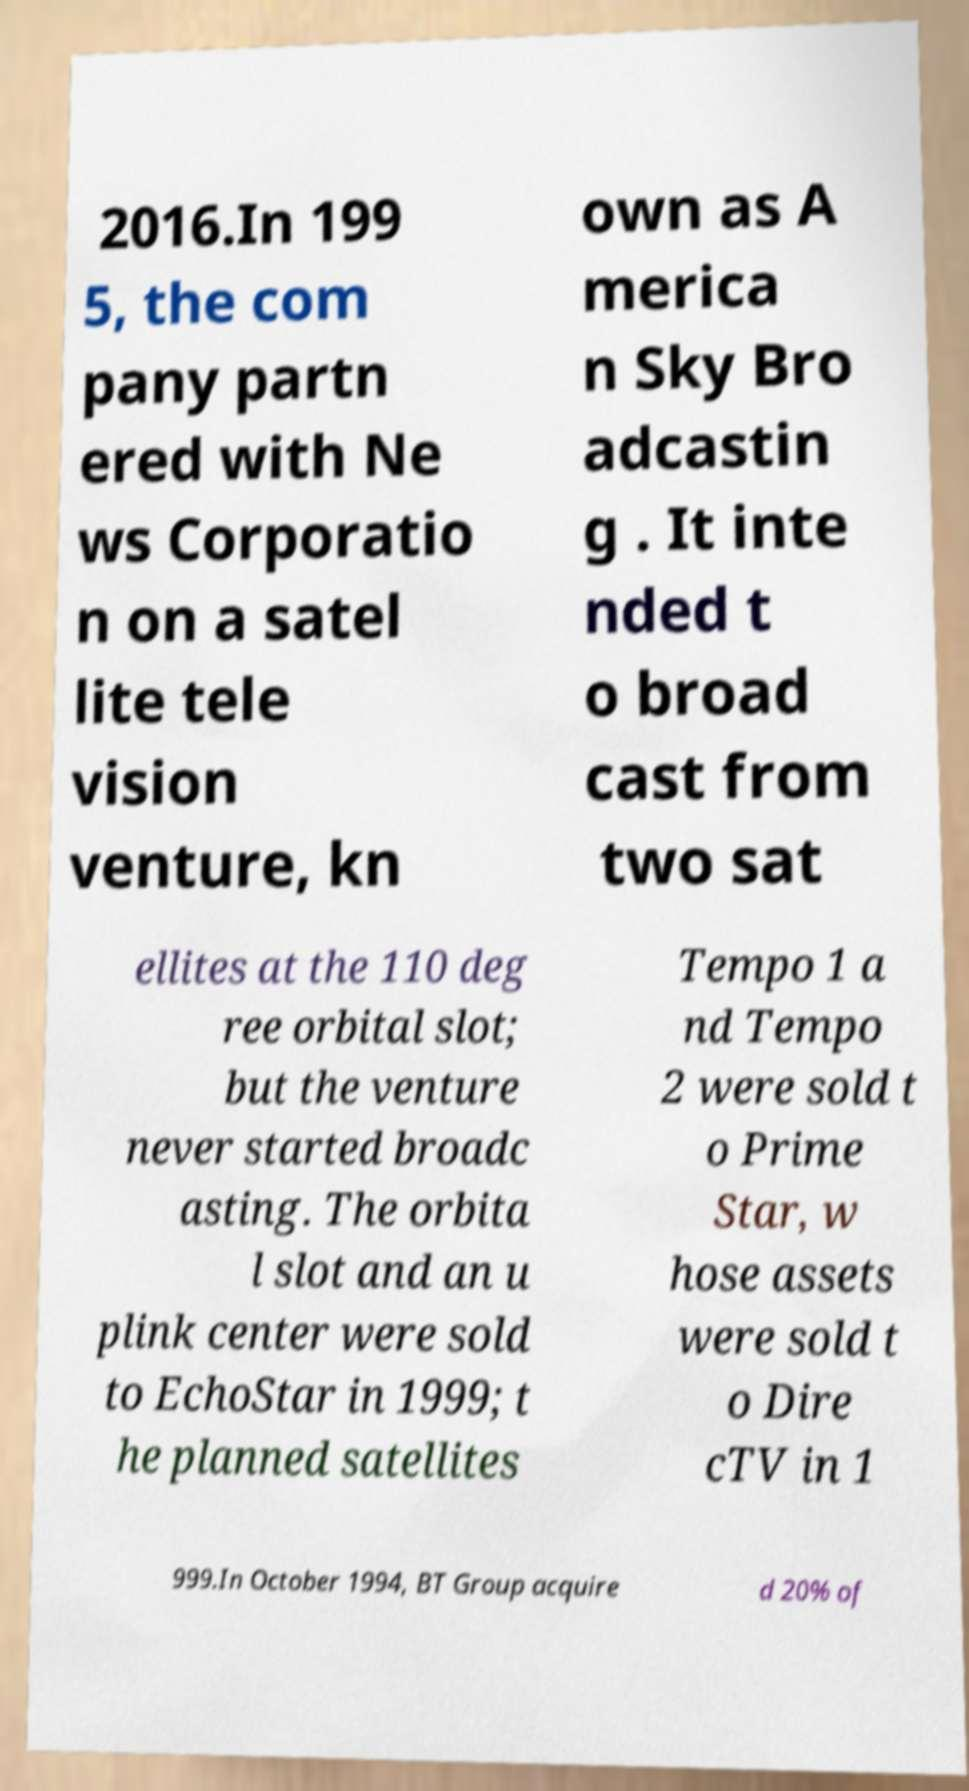Could you extract and type out the text from this image? 2016.In 199 5, the com pany partn ered with Ne ws Corporatio n on a satel lite tele vision venture, kn own as A merica n Sky Bro adcastin g . It inte nded t o broad cast from two sat ellites at the 110 deg ree orbital slot; but the venture never started broadc asting. The orbita l slot and an u plink center were sold to EchoStar in 1999; t he planned satellites Tempo 1 a nd Tempo 2 were sold t o Prime Star, w hose assets were sold t o Dire cTV in 1 999.In October 1994, BT Group acquire d 20% of 